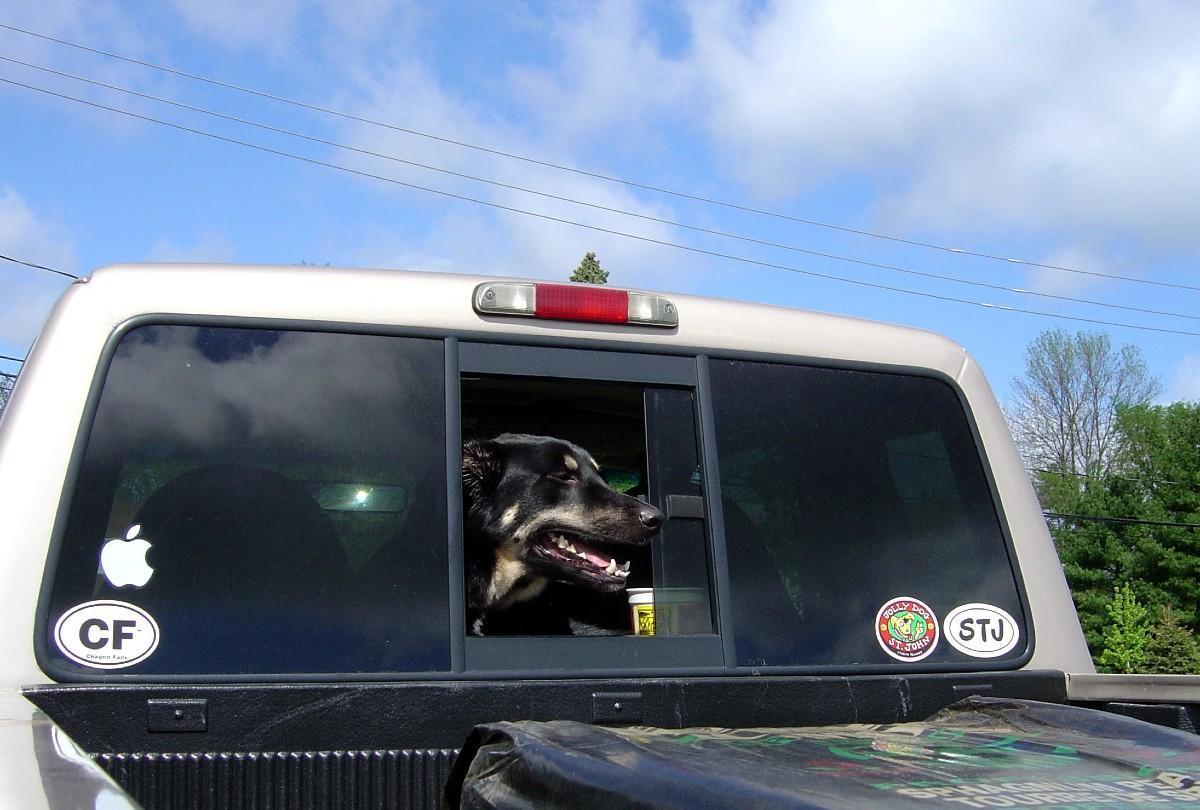How many dogs are pictured?
Give a very brief answer. 1. How many dogs are seen?
Give a very brief answer. 1. How many dogs are in the photo?
Give a very brief answer. 1. 